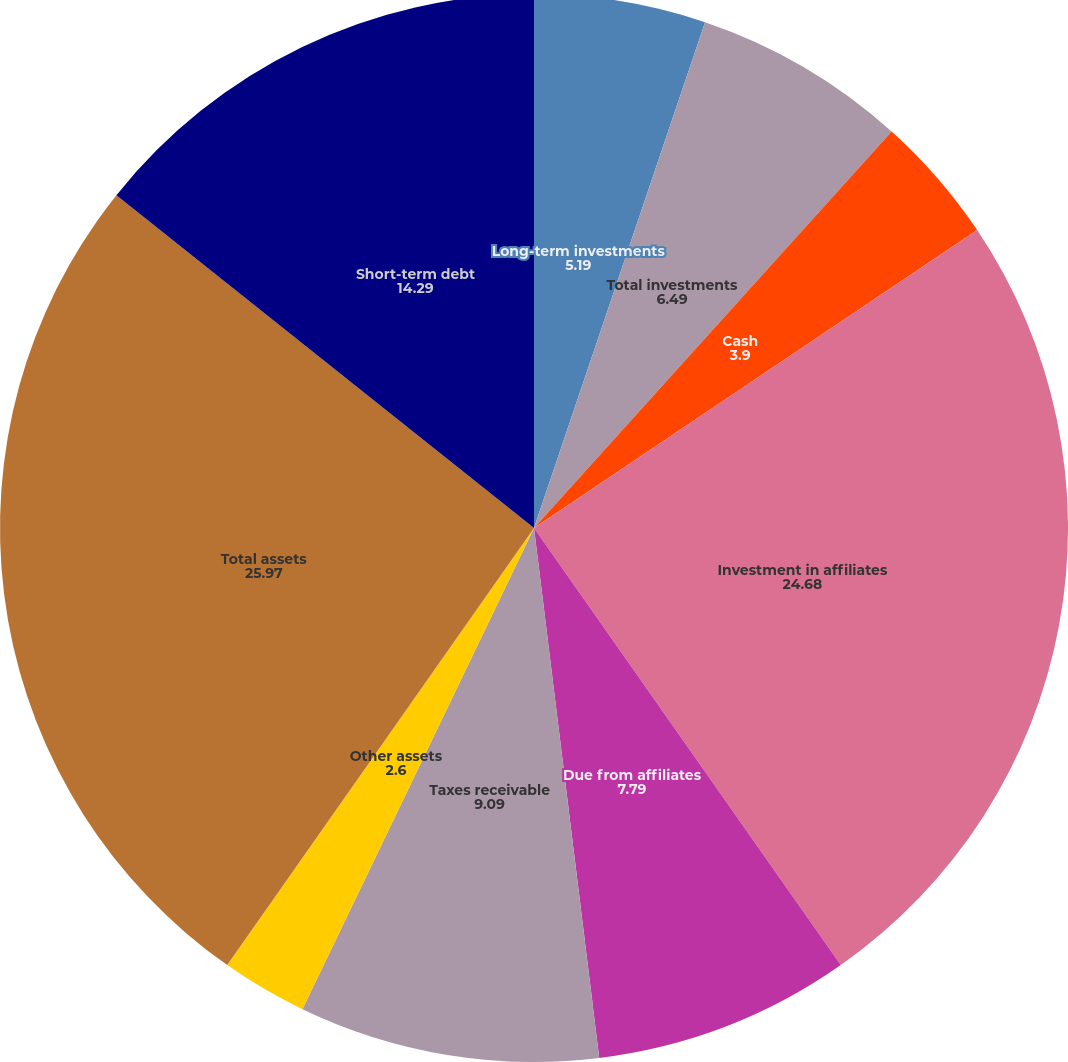Convert chart to OTSL. <chart><loc_0><loc_0><loc_500><loc_500><pie_chart><fcel>Long-term investments<fcel>Short-term investments<fcel>Total investments<fcel>Cash<fcel>Investment in affiliates<fcel>Due from affiliates<fcel>Taxes receivable<fcel>Other assets<fcel>Total assets<fcel>Short-term debt<nl><fcel>5.19%<fcel>0.0%<fcel>6.49%<fcel>3.9%<fcel>24.68%<fcel>7.79%<fcel>9.09%<fcel>2.6%<fcel>25.97%<fcel>14.29%<nl></chart> 